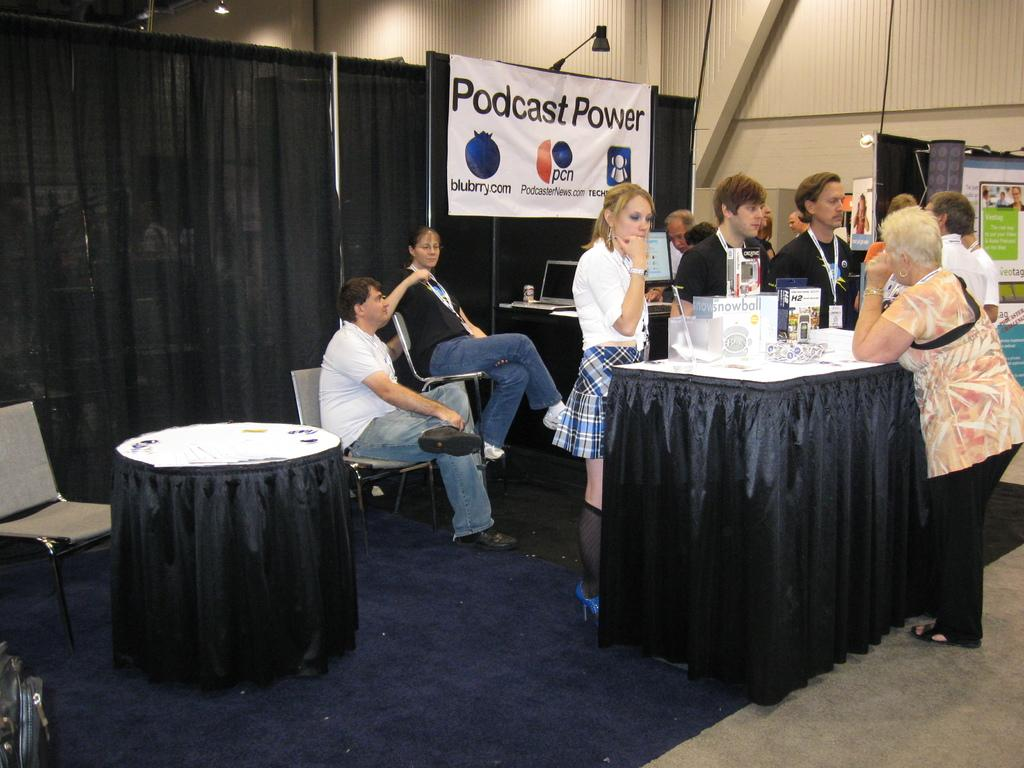How many people are present in the image? There are many people in the image. What are some of the people in the image doing? Some people are sitting, while others are standing. What can be seen on the wall in the image? There is a poster in the image. What is the color of the poster? The poster is black in color. What is present near the window in the image? There is a curtain in the image. What is the color of the curtain? The curtain is black in color. How many giants are visible in the image? There are no giants present in the image. What type of thing is the front of the room made of in the image? There is no specific information about the front of the room in the image, so it cannot be determined what it is made of. 